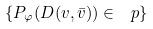<formula> <loc_0><loc_0><loc_500><loc_500>\{ P _ { \varphi } ( D ( v , \bar { v } ) ) \in \ p \}</formula> 